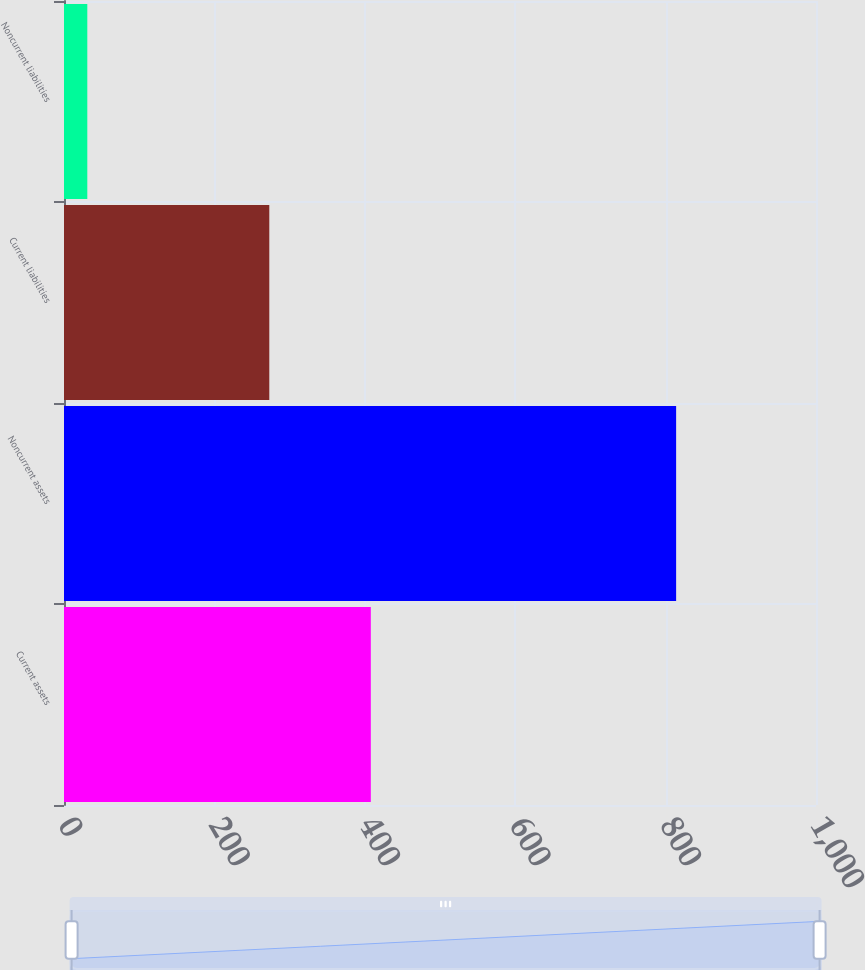Convert chart. <chart><loc_0><loc_0><loc_500><loc_500><bar_chart><fcel>Current assets<fcel>Noncurrent assets<fcel>Current liabilities<fcel>Noncurrent liabilities<nl><fcel>408<fcel>814<fcel>273<fcel>31<nl></chart> 